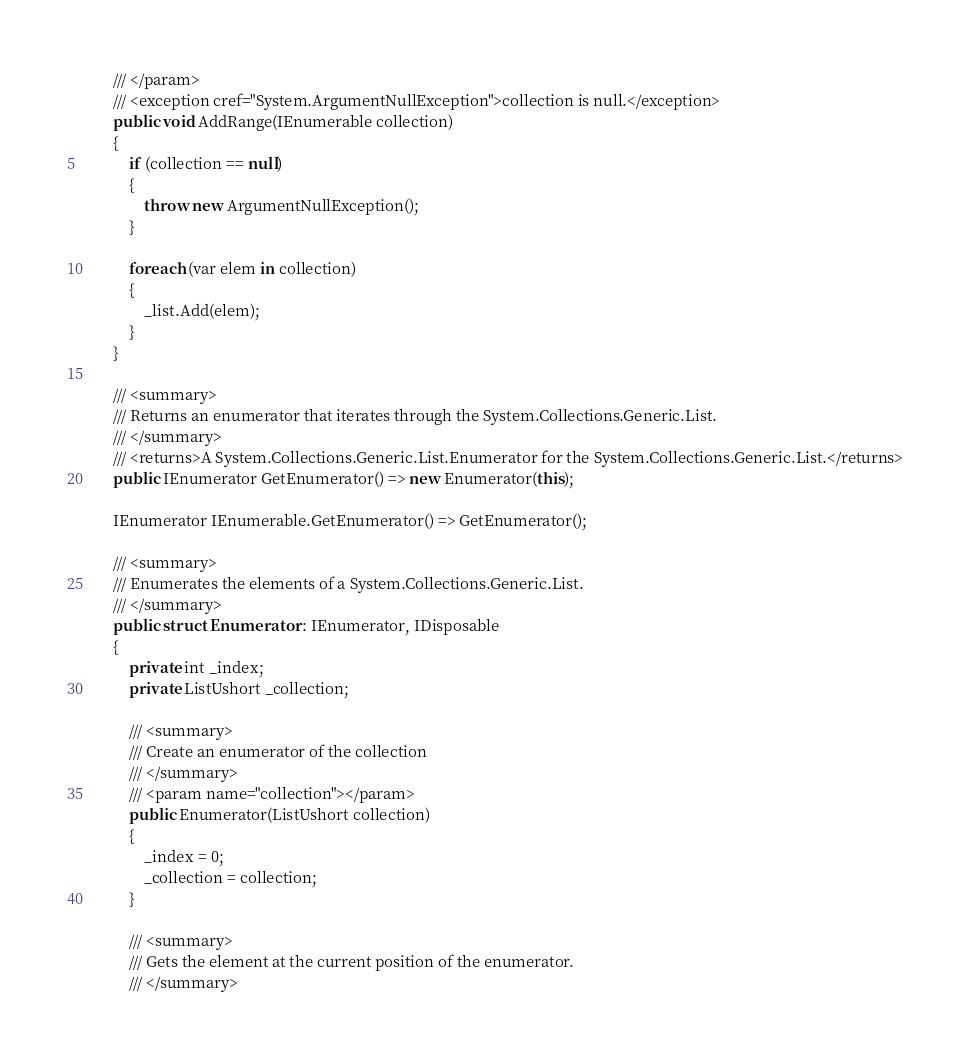Convert code to text. <code><loc_0><loc_0><loc_500><loc_500><_C#_>        /// </param>
        /// <exception cref="System.ArgumentNullException">collection is null.</exception>
        public void AddRange(IEnumerable collection)
        {
            if (collection == null)
            {
                throw new ArgumentNullException();
            }

            foreach (var elem in collection)
            {
                _list.Add(elem);
            }
        }

        /// <summary>
        /// Returns an enumerator that iterates through the System.Collections.Generic.List.
        /// </summary>
        /// <returns>A System.Collections.Generic.List.Enumerator for the System.Collections.Generic.List.</returns>
        public IEnumerator GetEnumerator() => new Enumerator(this);

        IEnumerator IEnumerable.GetEnumerator() => GetEnumerator();

        /// <summary>
        /// Enumerates the elements of a System.Collections.Generic.List.
        /// </summary>
        public struct Enumerator : IEnumerator, IDisposable
        {
            private int _index;
            private ListUshort _collection;

            /// <summary>
            /// Create an enumerator of the collection
            /// </summary>
            /// <param name="collection"></param>
            public Enumerator(ListUshort collection)
            {
                _index = 0;
                _collection = collection;
            }

            /// <summary>
            /// Gets the element at the current position of the enumerator.
            /// </summary></code> 